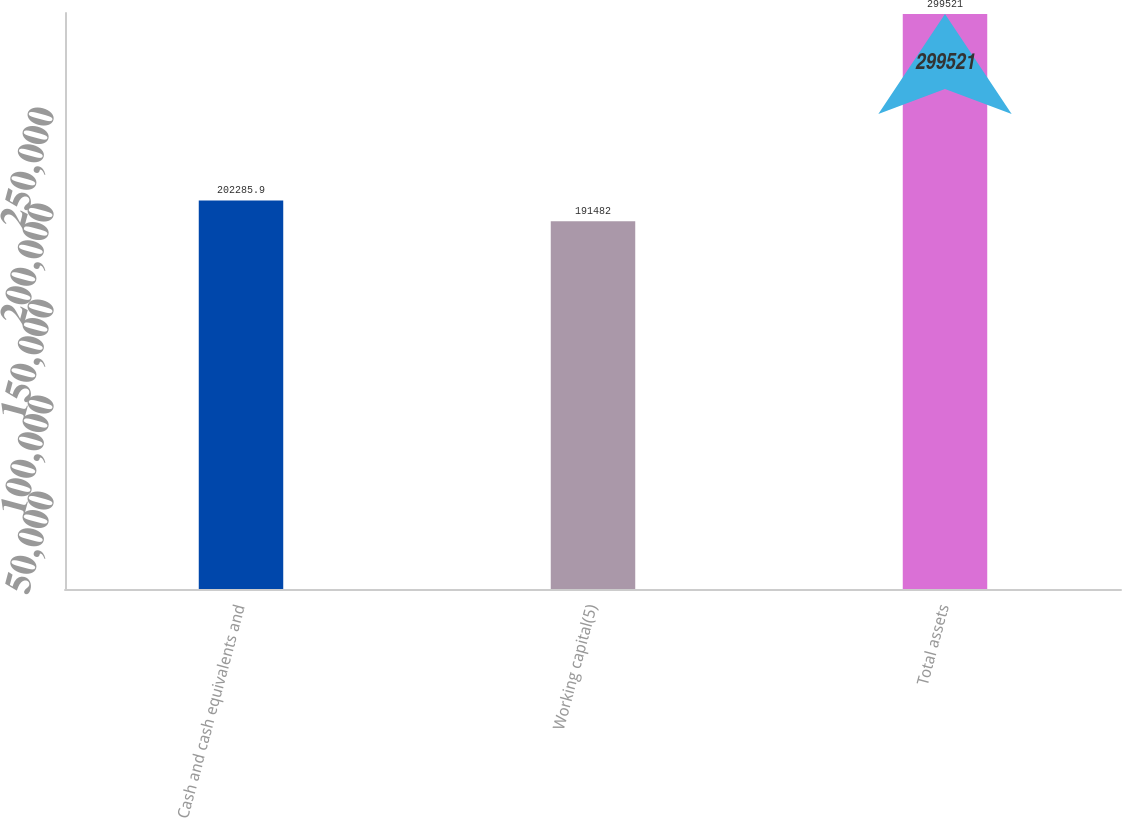Convert chart to OTSL. <chart><loc_0><loc_0><loc_500><loc_500><bar_chart><fcel>Cash and cash equivalents and<fcel>Working capital(5)<fcel>Total assets<nl><fcel>202286<fcel>191482<fcel>299521<nl></chart> 